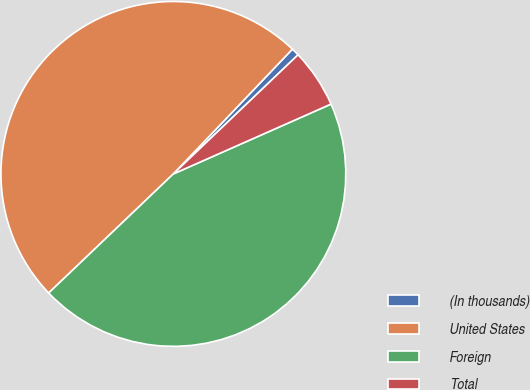Convert chart to OTSL. <chart><loc_0><loc_0><loc_500><loc_500><pie_chart><fcel>(In thousands)<fcel>United States<fcel>Foreign<fcel>Total<nl><fcel>0.74%<fcel>49.26%<fcel>44.5%<fcel>5.5%<nl></chart> 